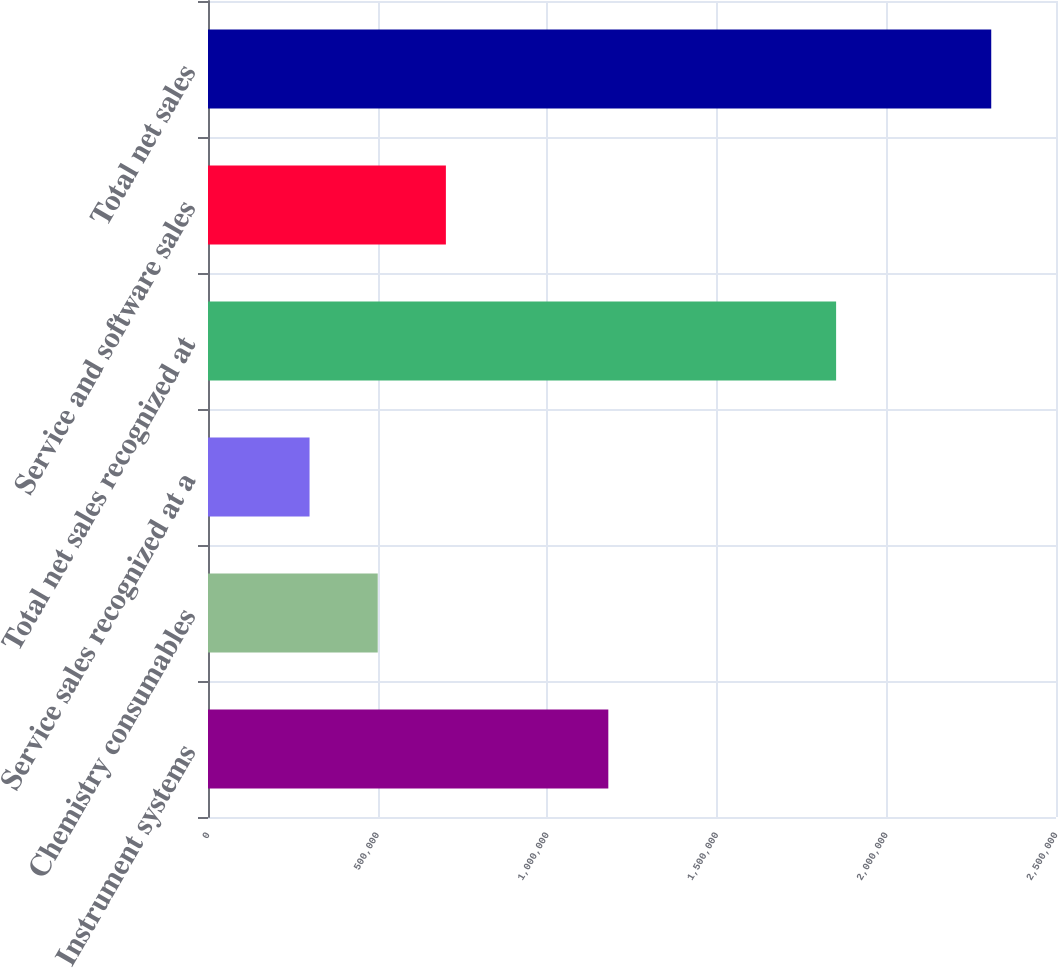Convert chart. <chart><loc_0><loc_0><loc_500><loc_500><bar_chart><fcel>Instrument systems<fcel>Chemistry consumables<fcel>Service sales recognized at a<fcel>Total net sales recognized at<fcel>Service and software sales<fcel>Total net sales<nl><fcel>1.18019e+06<fcel>500354<fcel>299385<fcel>1.85173e+06<fcel>701324<fcel>2.30908e+06<nl></chart> 